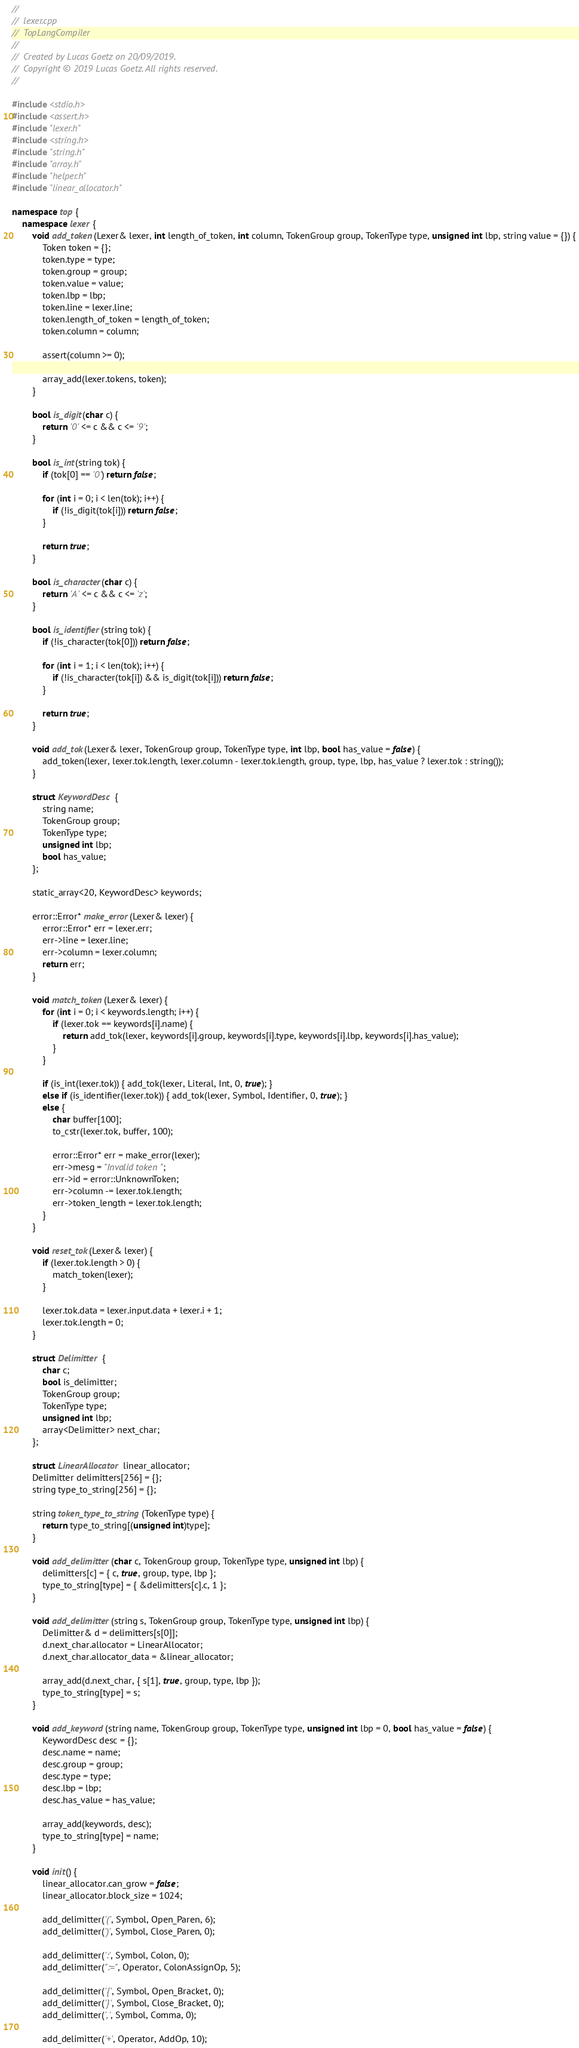<code> <loc_0><loc_0><loc_500><loc_500><_C++_>//
//  lexer.cpp
//  TopLangCompiler
//
//  Created by Lucas Goetz on 20/09/2019.
//  Copyright © 2019 Lucas Goetz. All rights reserved.
//

#include <stdio.h>
#include <assert.h>
#include "lexer.h"
#include <string.h>
#include "string.h"
#include "array.h"
#include "helper.h"
#include "linear_allocator.h"

namespace top {
    namespace lexer {
        void add_token(Lexer& lexer, int length_of_token, int column, TokenGroup group, TokenType type, unsigned int lbp, string value = {}) {
            Token token = {};
            token.type = type;
            token.group = group;
            token.value = value;
            token.lbp = lbp;
            token.line = lexer.line;
            token.length_of_token = length_of_token;
            token.column = column;
            
            assert(column >= 0);
            
            array_add(lexer.tokens, token);
        }
        
        bool is_digit(char c) {
            return '0' <= c && c <= '9';
        }
        
        bool is_int(string tok) {
            if (tok[0] == '0') return false;
            
            for (int i = 0; i < len(tok); i++) {
                if (!is_digit(tok[i])) return false;
            }
            
            return true;
        }
        
        bool is_character(char c) {
            return 'A' <= c && c <= 'z';
        }
        
        bool is_identifier(string tok) {
            if (!is_character(tok[0])) return false;
            
            for (int i = 1; i < len(tok); i++) {
                if (!is_character(tok[i]) && is_digit(tok[i])) return false;
            }
            
            return true;
        }
        
        void add_tok(Lexer& lexer, TokenGroup group, TokenType type, int lbp, bool has_value = false) {
            add_token(lexer, lexer.tok.length, lexer.column - lexer.tok.length, group, type, lbp, has_value ? lexer.tok : string());
        }
        
        struct KeywordDesc {
            string name;
            TokenGroup group;
            TokenType type;
            unsigned int lbp;
            bool has_value;
        };
        
        static_array<20, KeywordDesc> keywords;
        
        error::Error* make_error(Lexer& lexer) {
            error::Error* err = lexer.err;
            err->line = lexer.line;
            err->column = lexer.column;
            return err;
        }
        
        void match_token(Lexer& lexer) {
            for (int i = 0; i < keywords.length; i++) {
                if (lexer.tok == keywords[i].name) {
                    return add_tok(lexer, keywords[i].group, keywords[i].type, keywords[i].lbp, keywords[i].has_value);
                }
            }
            
            if (is_int(lexer.tok)) { add_tok(lexer, Literal, Int, 0, true); }
            else if (is_identifier(lexer.tok)) { add_tok(lexer, Symbol, Identifier, 0, true); }
            else {
                char buffer[100];
                to_cstr(lexer.tok, buffer, 100);
                
                error::Error* err = make_error(lexer);
                err->mesg = "Invalid token";
                err->id = error::UnknownToken;
                err->column -= lexer.tok.length;
                err->token_length = lexer.tok.length;
            }
        }
        
        void reset_tok(Lexer& lexer) {
            if (lexer.tok.length > 0) {
                match_token(lexer);
            }
            
            lexer.tok.data = lexer.input.data + lexer.i + 1;
            lexer.tok.length = 0;
        }
        
        struct Delimitter {
            char c;
            bool is_delimitter;
            TokenGroup group;
            TokenType type;
            unsigned int lbp;
            array<Delimitter> next_char;
        };
        
        struct LinearAllocator linear_allocator;
        Delimitter delimitters[256] = {};
        string type_to_string[256] = {};
        
        string token_type_to_string(TokenType type) {
            return type_to_string[(unsigned int)type];
        }
        
        void add_delimitter(char c, TokenGroup group, TokenType type, unsigned int lbp) {
            delimitters[c] = { c, true, group, type, lbp };
            type_to_string[type] = { &delimitters[c].c, 1 };
        }
        
        void add_delimitter(string s, TokenGroup group, TokenType type, unsigned int lbp) {
            Delimitter& d = delimitters[s[0]];
            d.next_char.allocator = LinearAllocator;
            d.next_char.allocator_data = &linear_allocator;

            array_add(d.next_char, { s[1], true, group, type, lbp });
            type_to_string[type] = s;
        }
        
        void add_keyword(string name, TokenGroup group, TokenType type, unsigned int lbp = 0, bool has_value = false) {
            KeywordDesc desc = {};
            desc.name = name;
            desc.group = group;
            desc.type = type;
            desc.lbp = lbp;
            desc.has_value = has_value;
            
            array_add(keywords, desc);
            type_to_string[type] = name;
        }
        
        void init() {
            linear_allocator.can_grow = false;
            linear_allocator.block_size = 1024;
            
            add_delimitter('(', Symbol, Open_Paren, 6);
            add_delimitter(')', Symbol, Close_Paren, 0);
            
            add_delimitter(':', Symbol, Colon, 0);
            add_delimitter(":=", Operator, ColonAssignOp, 5);
            
            add_delimitter('{', Symbol, Open_Bracket, 0);
            add_delimitter('}', Symbol, Close_Bracket, 0);
            add_delimitter(',', Symbol, Comma, 0);
            
            add_delimitter('+', Operator, AddOp, 10);</code> 